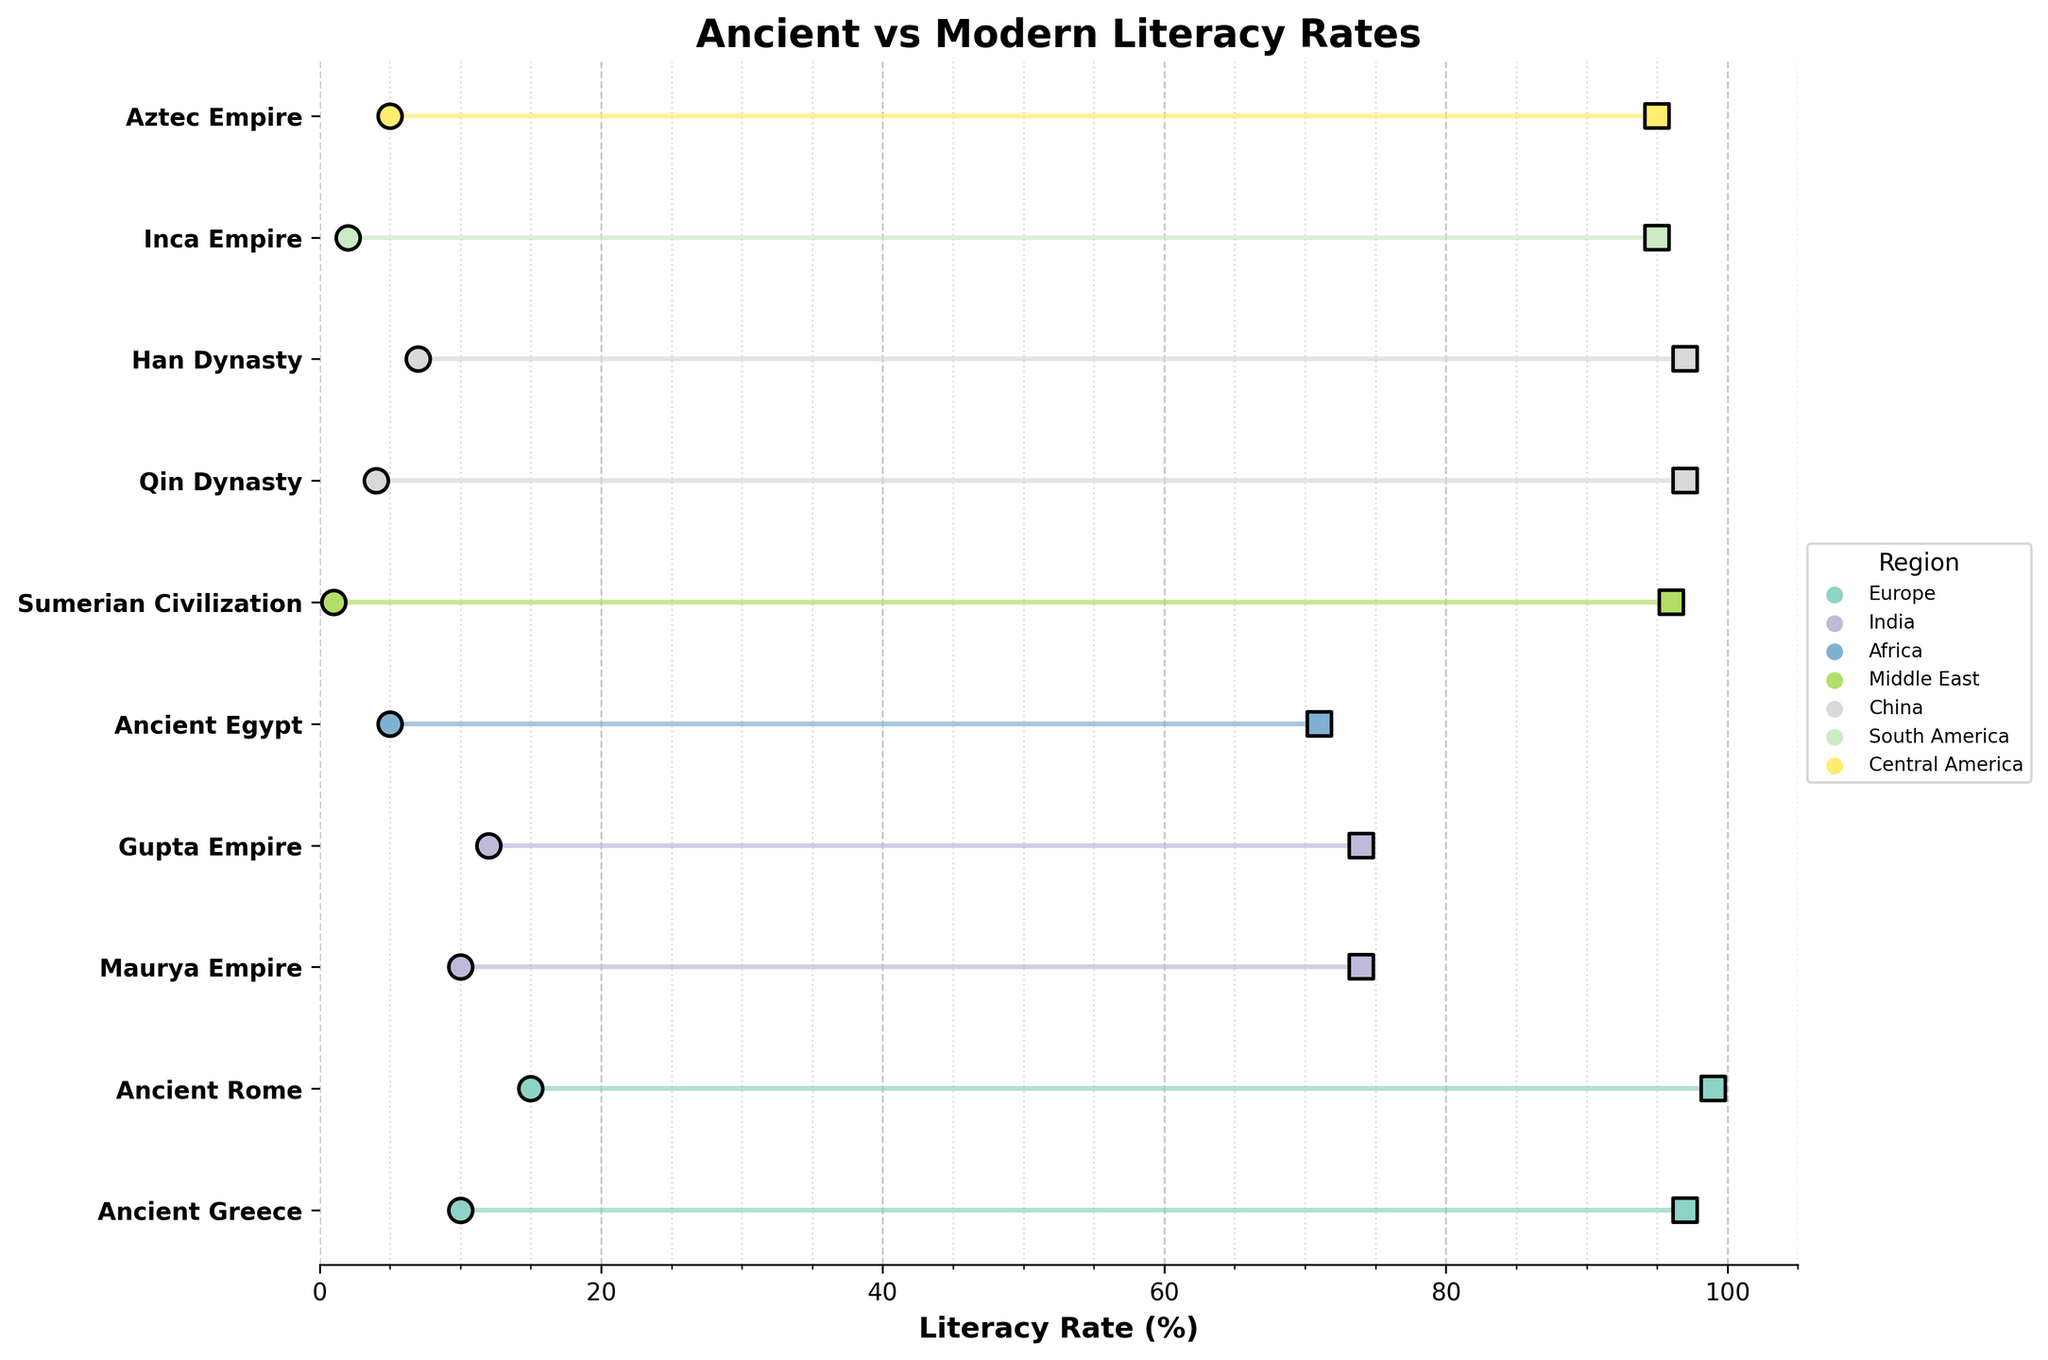What is the title of the figure? The title of the figure is usually displayed at the top of a plot. In this case, the title is given as "Ancient vs Modern Literacy Rates."
Answer: Ancient vs Modern Literacy Rates Which period has the highest modern literacy rate displayed in the figure? The modern literacy rates are displayed as square markers along the x-axis. From the figure, the highest value is 99%, which corresponds to Ancient Rome.
Answer: Ancient Rome How many regions are represented in the figure? Different regions are displayed using different colors. The legend on the right-hand side lists all unique regions. There are five unique regions mentioned: Europe, India, Africa, Middle East, and South America.
Answer: 5 What is the difference in literacy rates between the ancient and modern periods for the Gupta Empire? Find the two points for the Gupta Empire and calculate the difference between the modern literacy rate (74%) and the ancient literacy rate (12%). The difference is 74 - 12.
Answer: 62% Which region has the largest increase in literacy rate from ancient to modern times? To determine the largest increase, compare the difference between ancient and modern literacy rates for each region. The largest increase is seen with the Sumerian Civilization (96% - 1% = 95%).
Answer: Middle East (Sumerian Civilization) Calculate the average modern literacy rate of societies in India displayed in the figure. Only societies in India are considered. The Gupta Empire and Maurya Empire both have modern literacy rates of 74%. The average is (74 + 74) / 2.
Answer: 74% Which ancient period has the lowest literacy rate? The lowest ancient literacy rate corresponds to the period with the smallest dot along the x-axis. The Sumerian Civilization has the lowest rate at 1%.
Answer: Sumerian Civilization How many societies show an increase of more than 90% in literacy rate? Determine the difference for each society and count how many exceed 90%. Sumerian Civilization (95%), Qin Dynasty (93%), and Han Dynasty (90%). However, only Sumerian Civilization and Qin Dynasty exceed 90%.
Answer: 2 What is the range of modern literacy rates for societies in Europe? The modern literacy rates for Europe are 97% (Ancient Greece) and 99% (Ancient Rome). The range is the difference between these values, 99 - 97.
Answer: 2% Is there any region where ancient and modern literacy rates are the same? Compare the ancient and modern literacy rates for each region visually. None of the societies have identical ancient and modern literacy rates.
Answer: No 